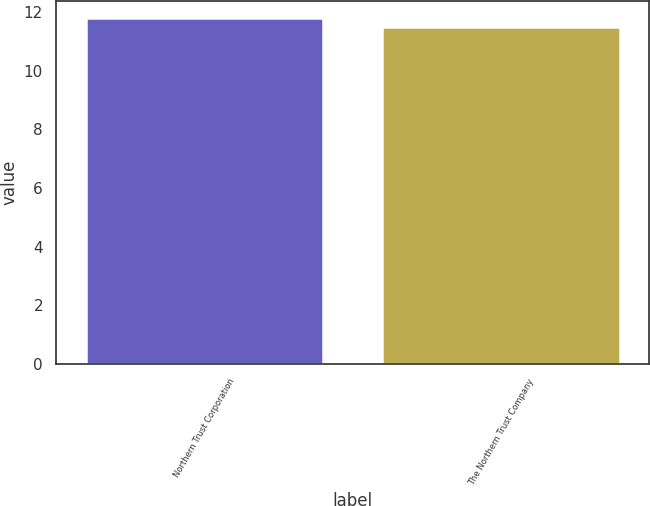<chart> <loc_0><loc_0><loc_500><loc_500><bar_chart><fcel>Northern Trust Corporation<fcel>The Northern Trust Company<nl><fcel>11.8<fcel>11.5<nl></chart> 